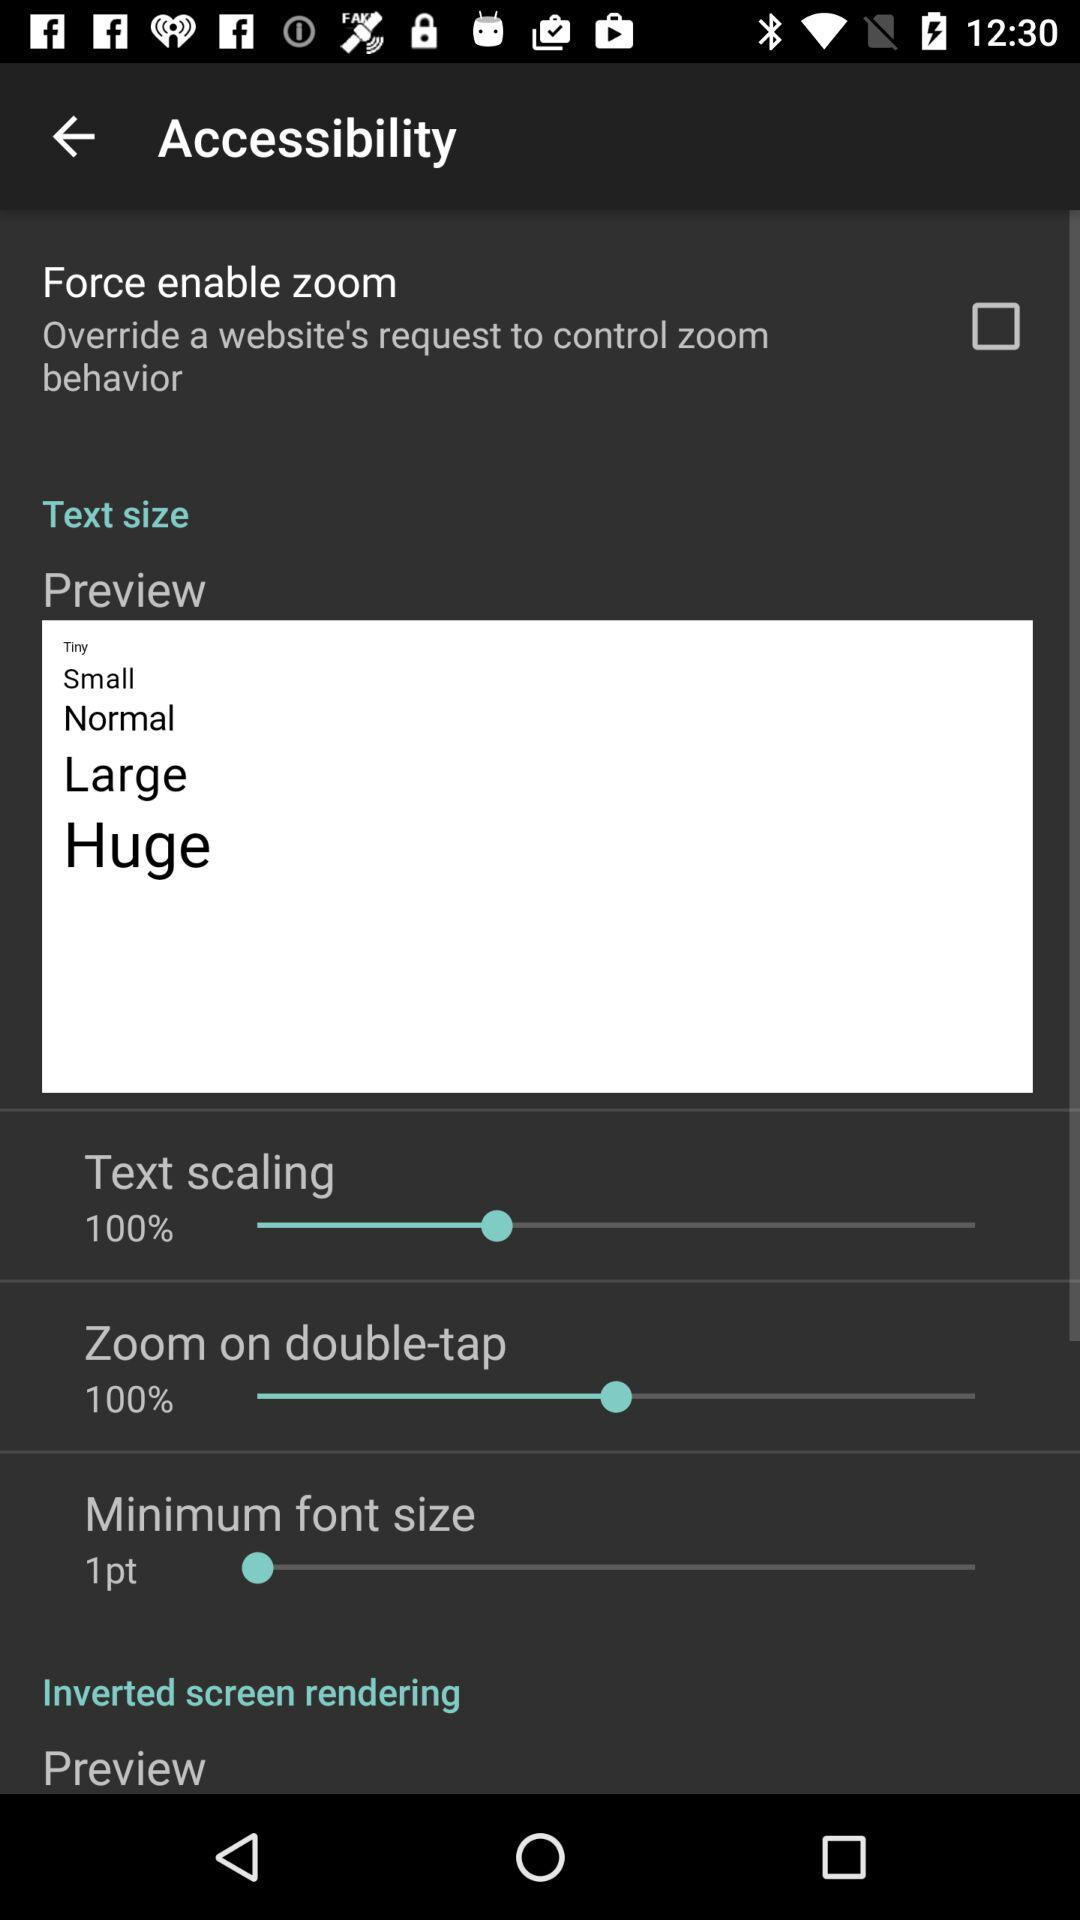What is the "Zoom on double-tap" percentage? The "Zoom on double-tap" percentage is 100. 